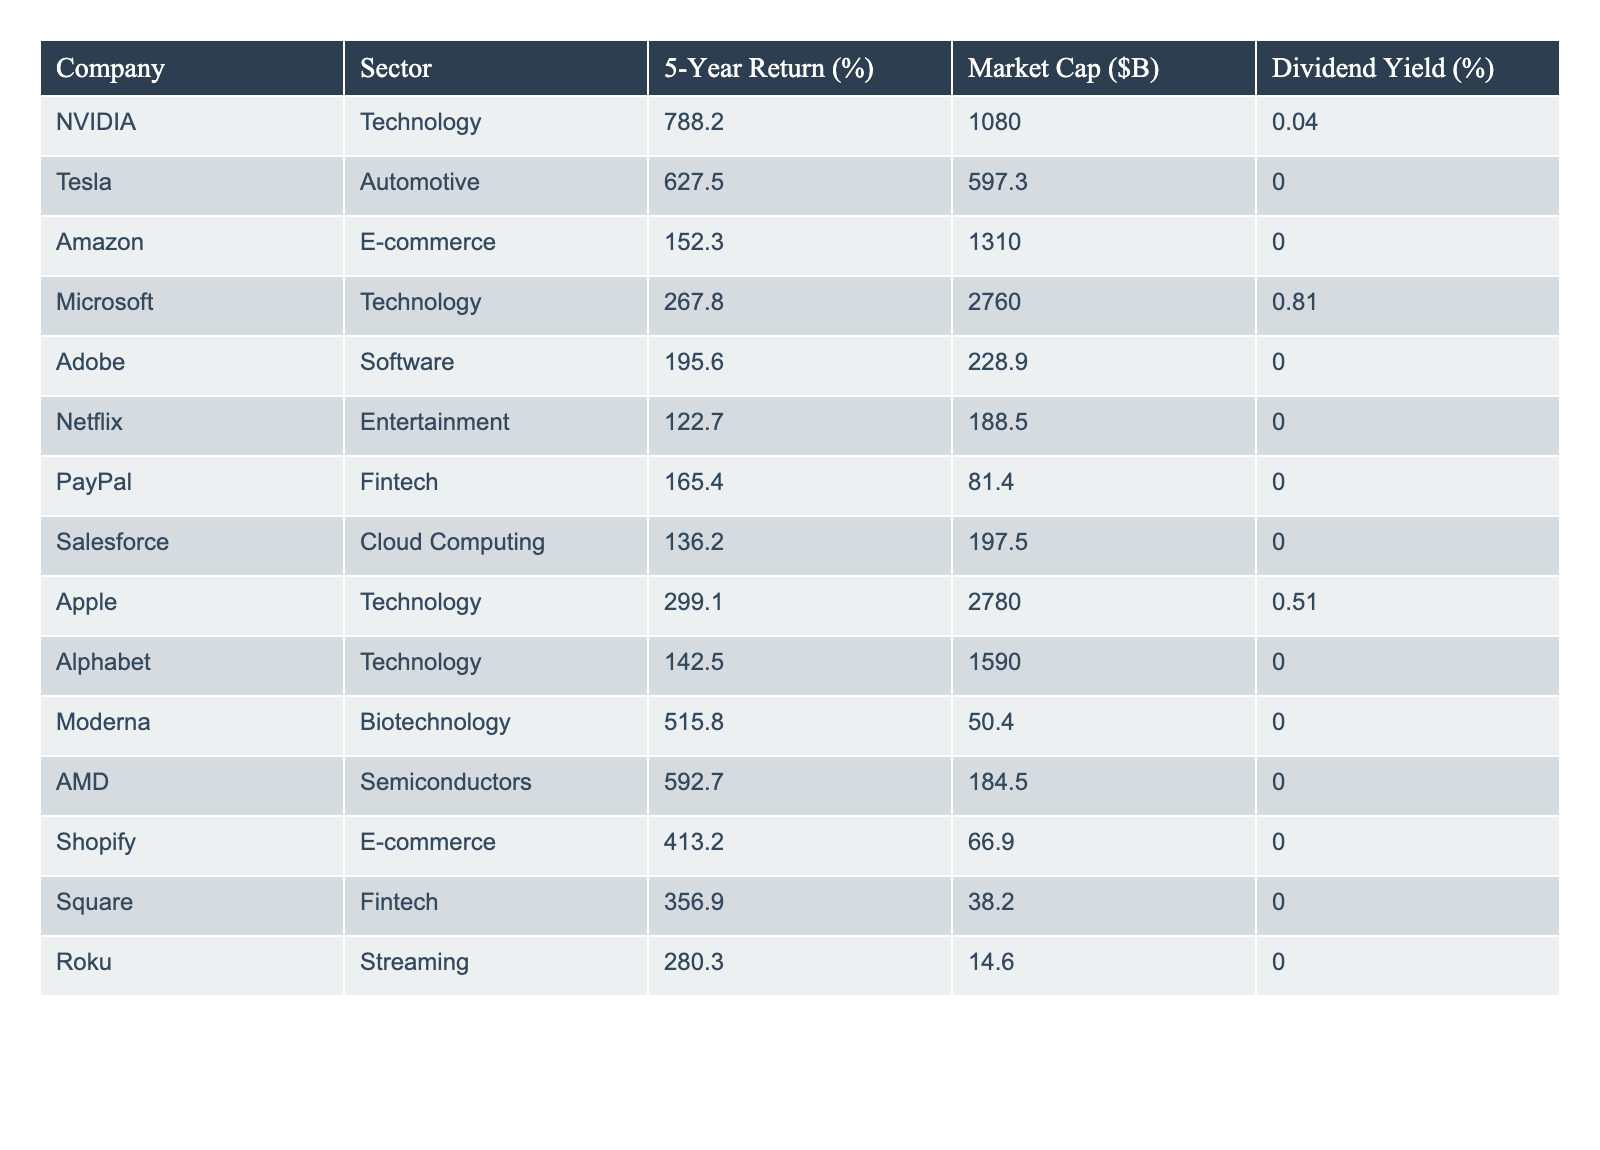What company had the highest 5-year return? By scanning the "5-Year Return (%)" column, I see that NVIDIA has the highest return at 788.2%.
Answer: NVIDIA What is the market cap of Apple? Referring to the "Market Cap ($B)" column, Apple's market cap is 2,780 billion dollars.
Answer: 2,780B Which sector has the most companies listed in this table? Reviewing the table, the Technology sector has the most entries, including NVIDIA, Microsoft, Apple, Adobe, Alphabet, and AMD.
Answer: Technology What is the average 5-year return of the fintech companies listed? The fintech companies are PayPal and Square. Their returns are 165.4% and 356.9%. The average is (165.4 + 356.9) / 2 = 261.15%.
Answer: 261.15% Is there any company that has a dividend yield? Upon checking the "Dividend Yield (%)" column, both Microsoft and Apple are the only companies with non-zero yields.
Answer: Yes Which two companies have the highest 5-year returns, and what is the combined total? The two highest returns are NVIDIA (788.2%) and Tesla (627.5%). Adding them yields 788.2 + 627.5 = 1,415.7%.
Answer: 1,415.7% What is the Market Cap difference between Tesla and Amazon? Tesla's market cap is 597.3 billion and Amazon's is 1,310 billion. The difference is 1,310 - 597.3 = 712.7 billion dollars.
Answer: 712.7B How many sectors are represented in the table? By examining the sector column, the sectors present are Technology, Automotive, E-commerce, Software, Entertainment, Fintech, Cloud Computing, Semiconductors, and Biotechnology, totaling 9 sectors.
Answer: 9 What is the highest dividend yield among the companies listed? The highest dividend yield is 0.81%, which belongs to Microsoft.
Answer: 0.81% If you were to invest in companies with no dividend yield, how many would that be? Counting all the companies listed, PayPal, Square, Tesla, and others show a dividend yield of 0%. Excluding Microsoft and Apple, there are 12 companies with no dividend yield.
Answer: 12 